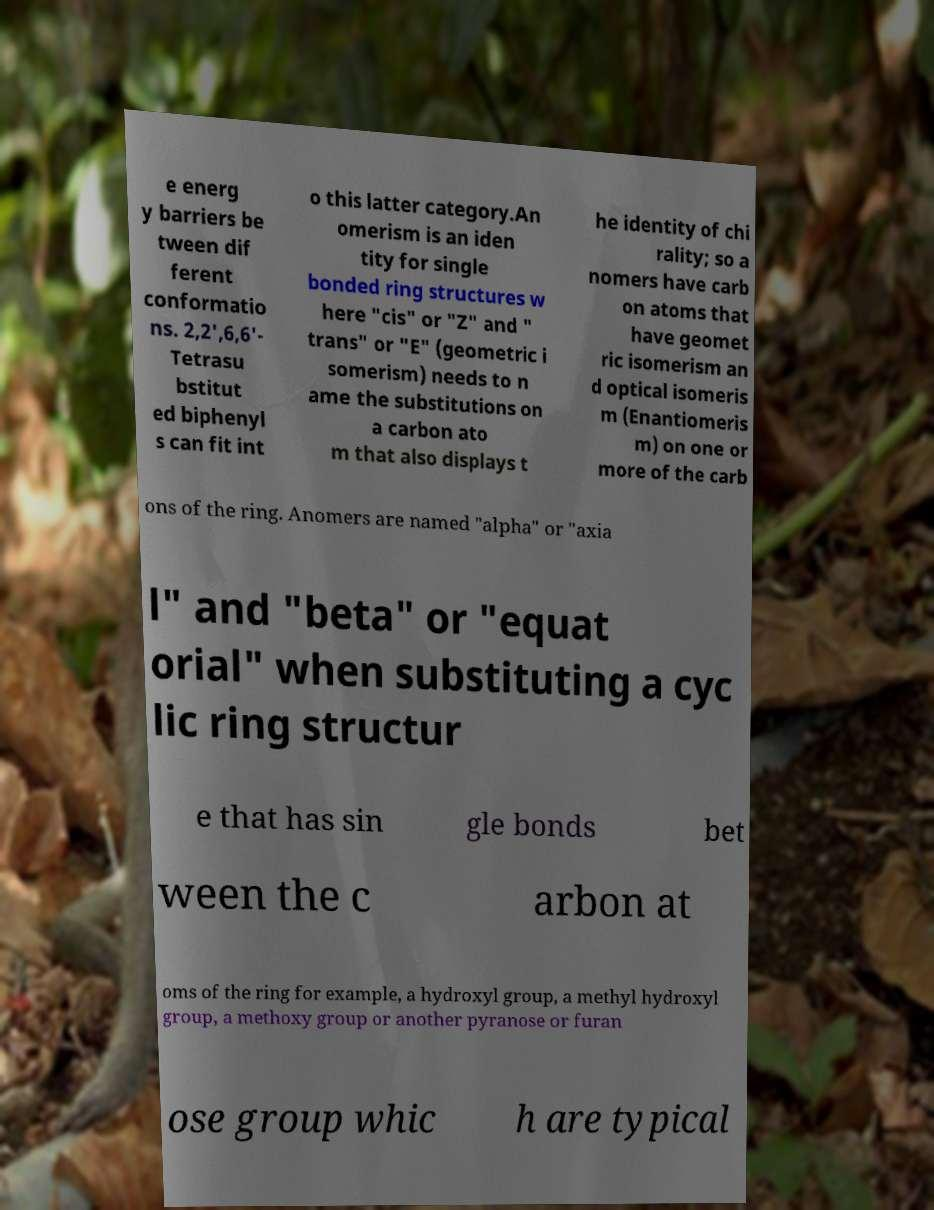What messages or text are displayed in this image? I need them in a readable, typed format. e energ y barriers be tween dif ferent conformatio ns. 2,2',6,6'- Tetrasu bstitut ed biphenyl s can fit int o this latter category.An omerism is an iden tity for single bonded ring structures w here "cis" or "Z" and " trans" or "E" (geometric i somerism) needs to n ame the substitutions on a carbon ato m that also displays t he identity of chi rality; so a nomers have carb on atoms that have geomet ric isomerism an d optical isomeris m (Enantiomeris m) on one or more of the carb ons of the ring. Anomers are named "alpha" or "axia l" and "beta" or "equat orial" when substituting a cyc lic ring structur e that has sin gle bonds bet ween the c arbon at oms of the ring for example, a hydroxyl group, a methyl hydroxyl group, a methoxy group or another pyranose or furan ose group whic h are typical 